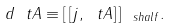Convert formula to latex. <formula><loc_0><loc_0><loc_500><loc_500>d \ t A \equiv [ \, [ j , \ t A ] \, ] _ { \ s h a l f } .</formula> 